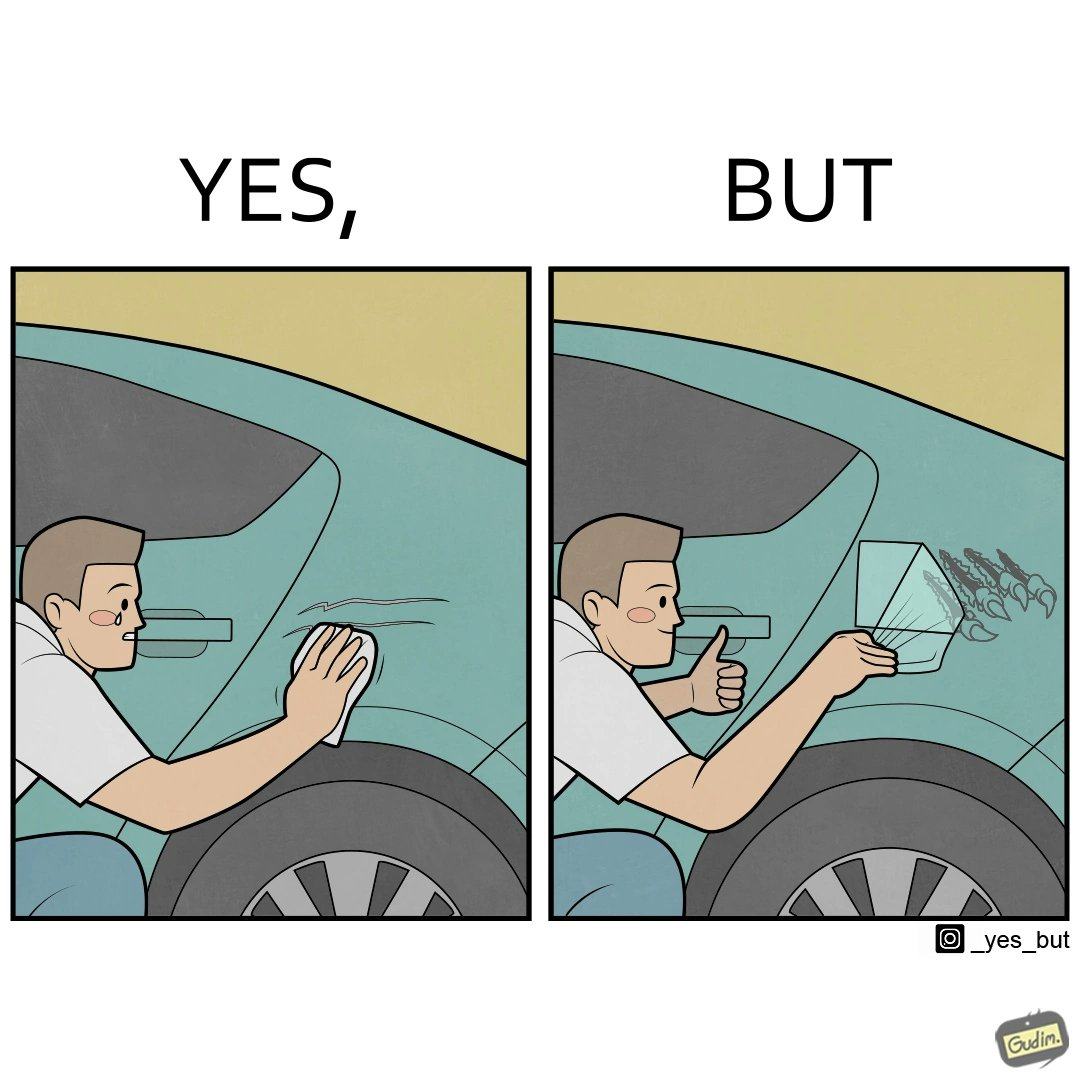Provide a description of this image. The image is ironic, because the person who cries over the scratches on his car but applies stickers on his car happily which is quite dual nature of the person 